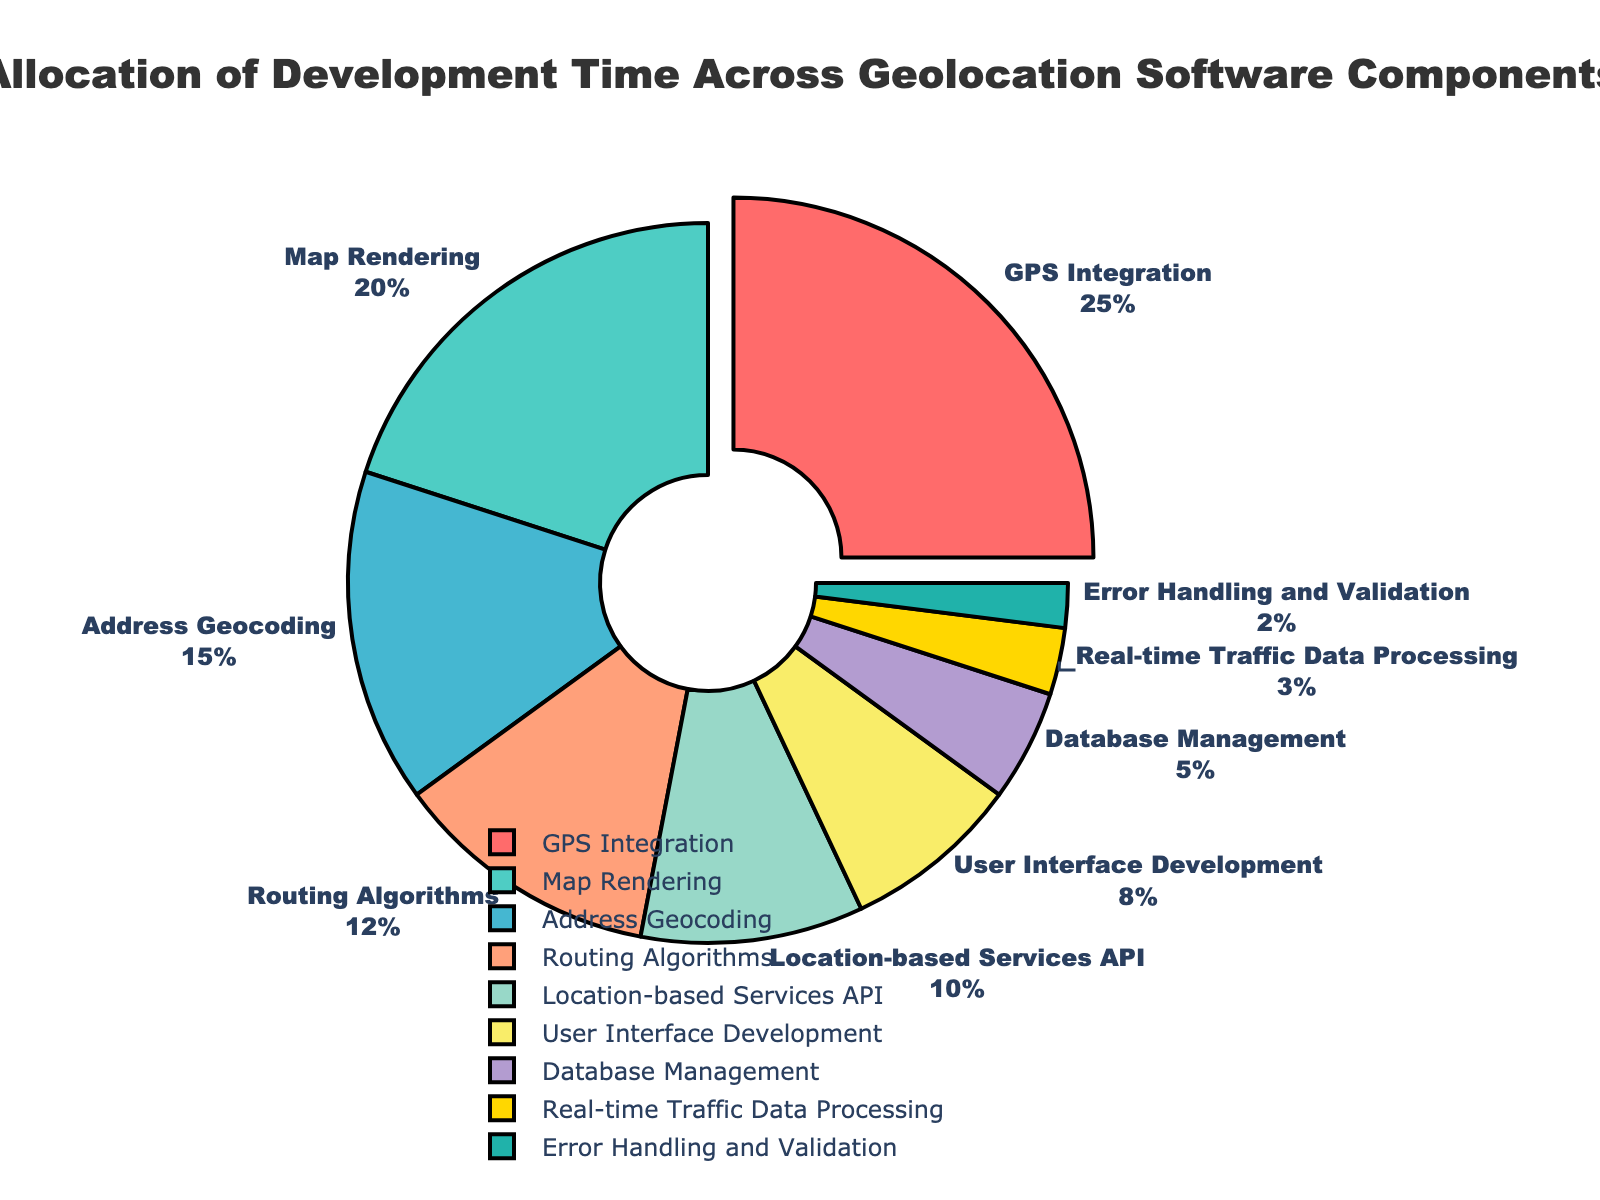Which component consumes the largest share of development time and what is its percentage? The largest segment in the pie chart, representing the component with the highest allocation, is clearly marked on the chart as "GPS Integration" with a 25% share.
Answer: GPS Integration, 25% What is the combined percentage of time spent on Address Geocoding and Database Management? To find the combined percentage, sum the percentages for Address Geocoding (15%) and Database Management (5%). Therefore, 15% + 5% = 20%.
Answer: 20% Which component has a lower percentage allocation than Location-based Services API, and what are their percentages? Location-based Services API has a 10% allocation. Components with lower percentages are User Interface Development (8%), Database Management (5%), Real-time Traffic Data Processing (3%), and Error Handling and Validation (2%).
Answer: User Interface Development 8%, Database Management 5%, Real-time Traffic Data Processing 3%, Error Handling and Validation 2% What is the difference in percentage allocation between Map Rendering and Routing Algorithms? Map Rendering has a 20% allocation, whereas Routing Algorithms have a 12% allocation. The difference is 20% - 12%.
Answer: 8% Which components, if combined, make up 50% of the development time? The components and their percentages are: GPS Integration (25%), Map Rendering (20%), Address Geocoding (15%), Routing Algorithms (12%), Location-based Services API (10%), User Interface Development (8%), Database Management (5%), Real-time Traffic Data Processing (3%), Error Handling and Validation (2%). Combining GPS Integration (25%) and Map Rendering (20%) gives 45%; adding Address Geocoding (15%) would exceed 50%. However, combining GPS Integration (25%), Map Rendering (20%), and Location-based Services API (10%) sums exactly to 55%, which is the closest we can get without exceeding 50%.
Answer: GPS Integration, Map Rendering, Location-based Services API Which segment is highlighted or pulled out of the pie chart? The pie chart pulls out the segment for "GPS Integration," emphasizing its importance as the largest allocation.
Answer: GPS Integration Identify the components with a percentage allocation less than 10%, and explain their combined percentage. Components with less than 10% allocation are User Interface Development (8%), Database Management (5%), Real-time Traffic Data Processing (3%), and Error Handling and Validation (2%). Their combined percentage is 8% + 5% + 3% + 2% = 18%.
Answer: User Interface Development, Database Management, Real-time Traffic Data Processing, Error Handling and Validation, 18% What is the average percentage allocation for GPS Integration, Map Rendering, and Address Geocoding? To calculate the average, add the percentages for GPS Integration (25%), Map Rendering (20%), and Address Geocoding (15%) then divide by 3. (25% + 20% + 15%) / 3 = 60% / 3 = 20%.
Answer: 20% Which component has the same textual style as all the others but a distinct visual attribute? All components share the same textual style (Arial Black font, size 12), but the "GPS Integration" segment is distinct due to being visually pulled out from the pie chart.
Answer: GPS Integration 